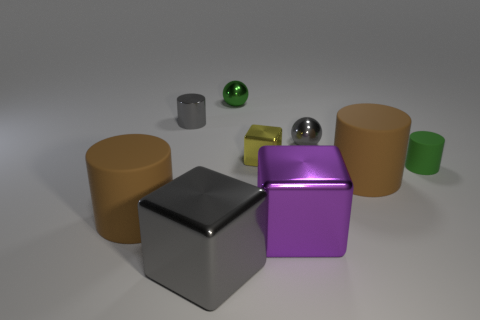Add 1 big cylinders. How many objects exist? 10 Subtract all large gray metallic cubes. How many cubes are left? 2 Subtract all green cylinders. How many cylinders are left? 3 Subtract 0 red balls. How many objects are left? 9 Subtract all cylinders. How many objects are left? 5 Subtract 1 cubes. How many cubes are left? 2 Subtract all green cubes. Subtract all yellow cylinders. How many cubes are left? 3 Subtract all gray cylinders. How many gray balls are left? 1 Subtract all green objects. Subtract all gray metallic cylinders. How many objects are left? 6 Add 4 big purple things. How many big purple things are left? 5 